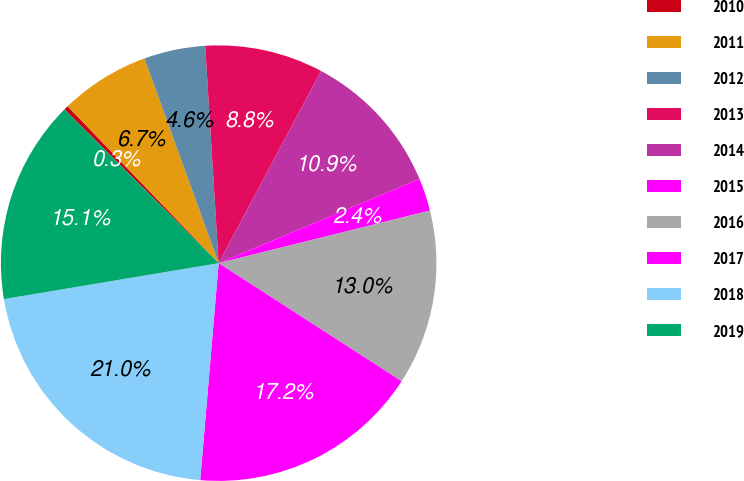Convert chart. <chart><loc_0><loc_0><loc_500><loc_500><pie_chart><fcel>2010<fcel>2011<fcel>2012<fcel>2013<fcel>2014<fcel>2015<fcel>2016<fcel>2017<fcel>2018<fcel>2019<nl><fcel>0.33%<fcel>6.66%<fcel>4.55%<fcel>8.78%<fcel>10.89%<fcel>2.44%<fcel>13.0%<fcel>17.23%<fcel>21.01%<fcel>15.11%<nl></chart> 